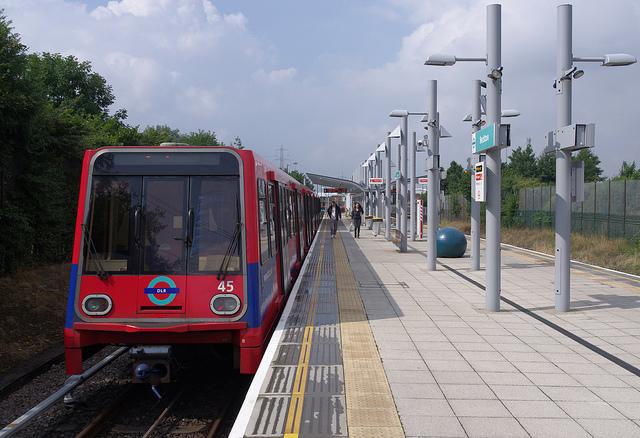What color is the front of this train?
Write a very short answer. Red. Where is the trolley getting power?
Answer briefly. Track. How many red train cars are in this image?
Concise answer only. 1. What numbers are on the train?
Short answer required. 45. Is this train moving?
Keep it brief. No. How many trains are there?
Concise answer only. 1. What are the colors on the train?
Keep it brief. Red and blue. What two numbers are on the front of the train?
Concise answer only. 45. 